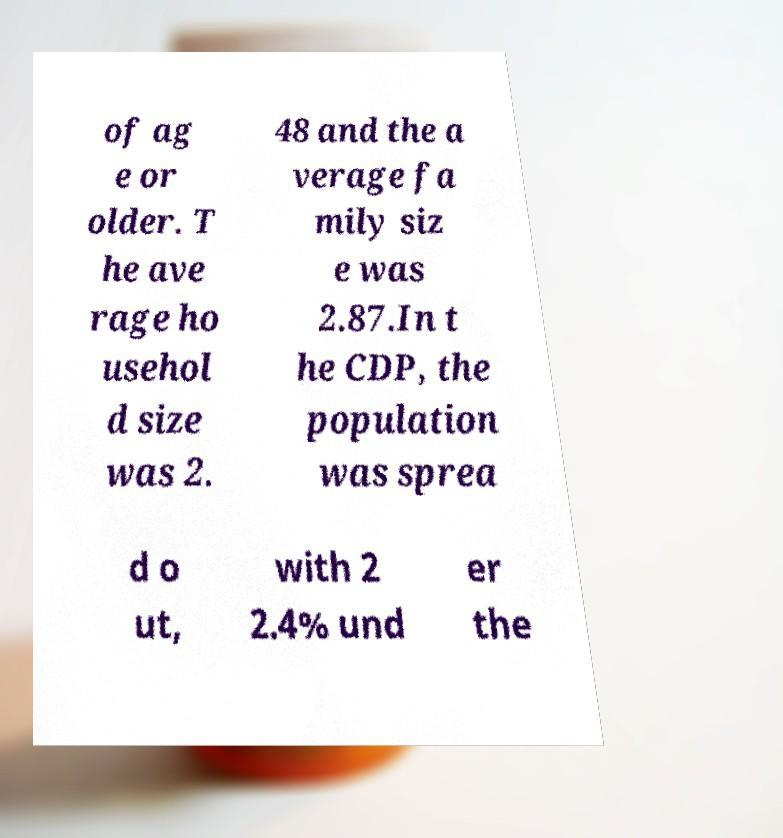I need the written content from this picture converted into text. Can you do that? of ag e or older. T he ave rage ho usehol d size was 2. 48 and the a verage fa mily siz e was 2.87.In t he CDP, the population was sprea d o ut, with 2 2.4% und er the 